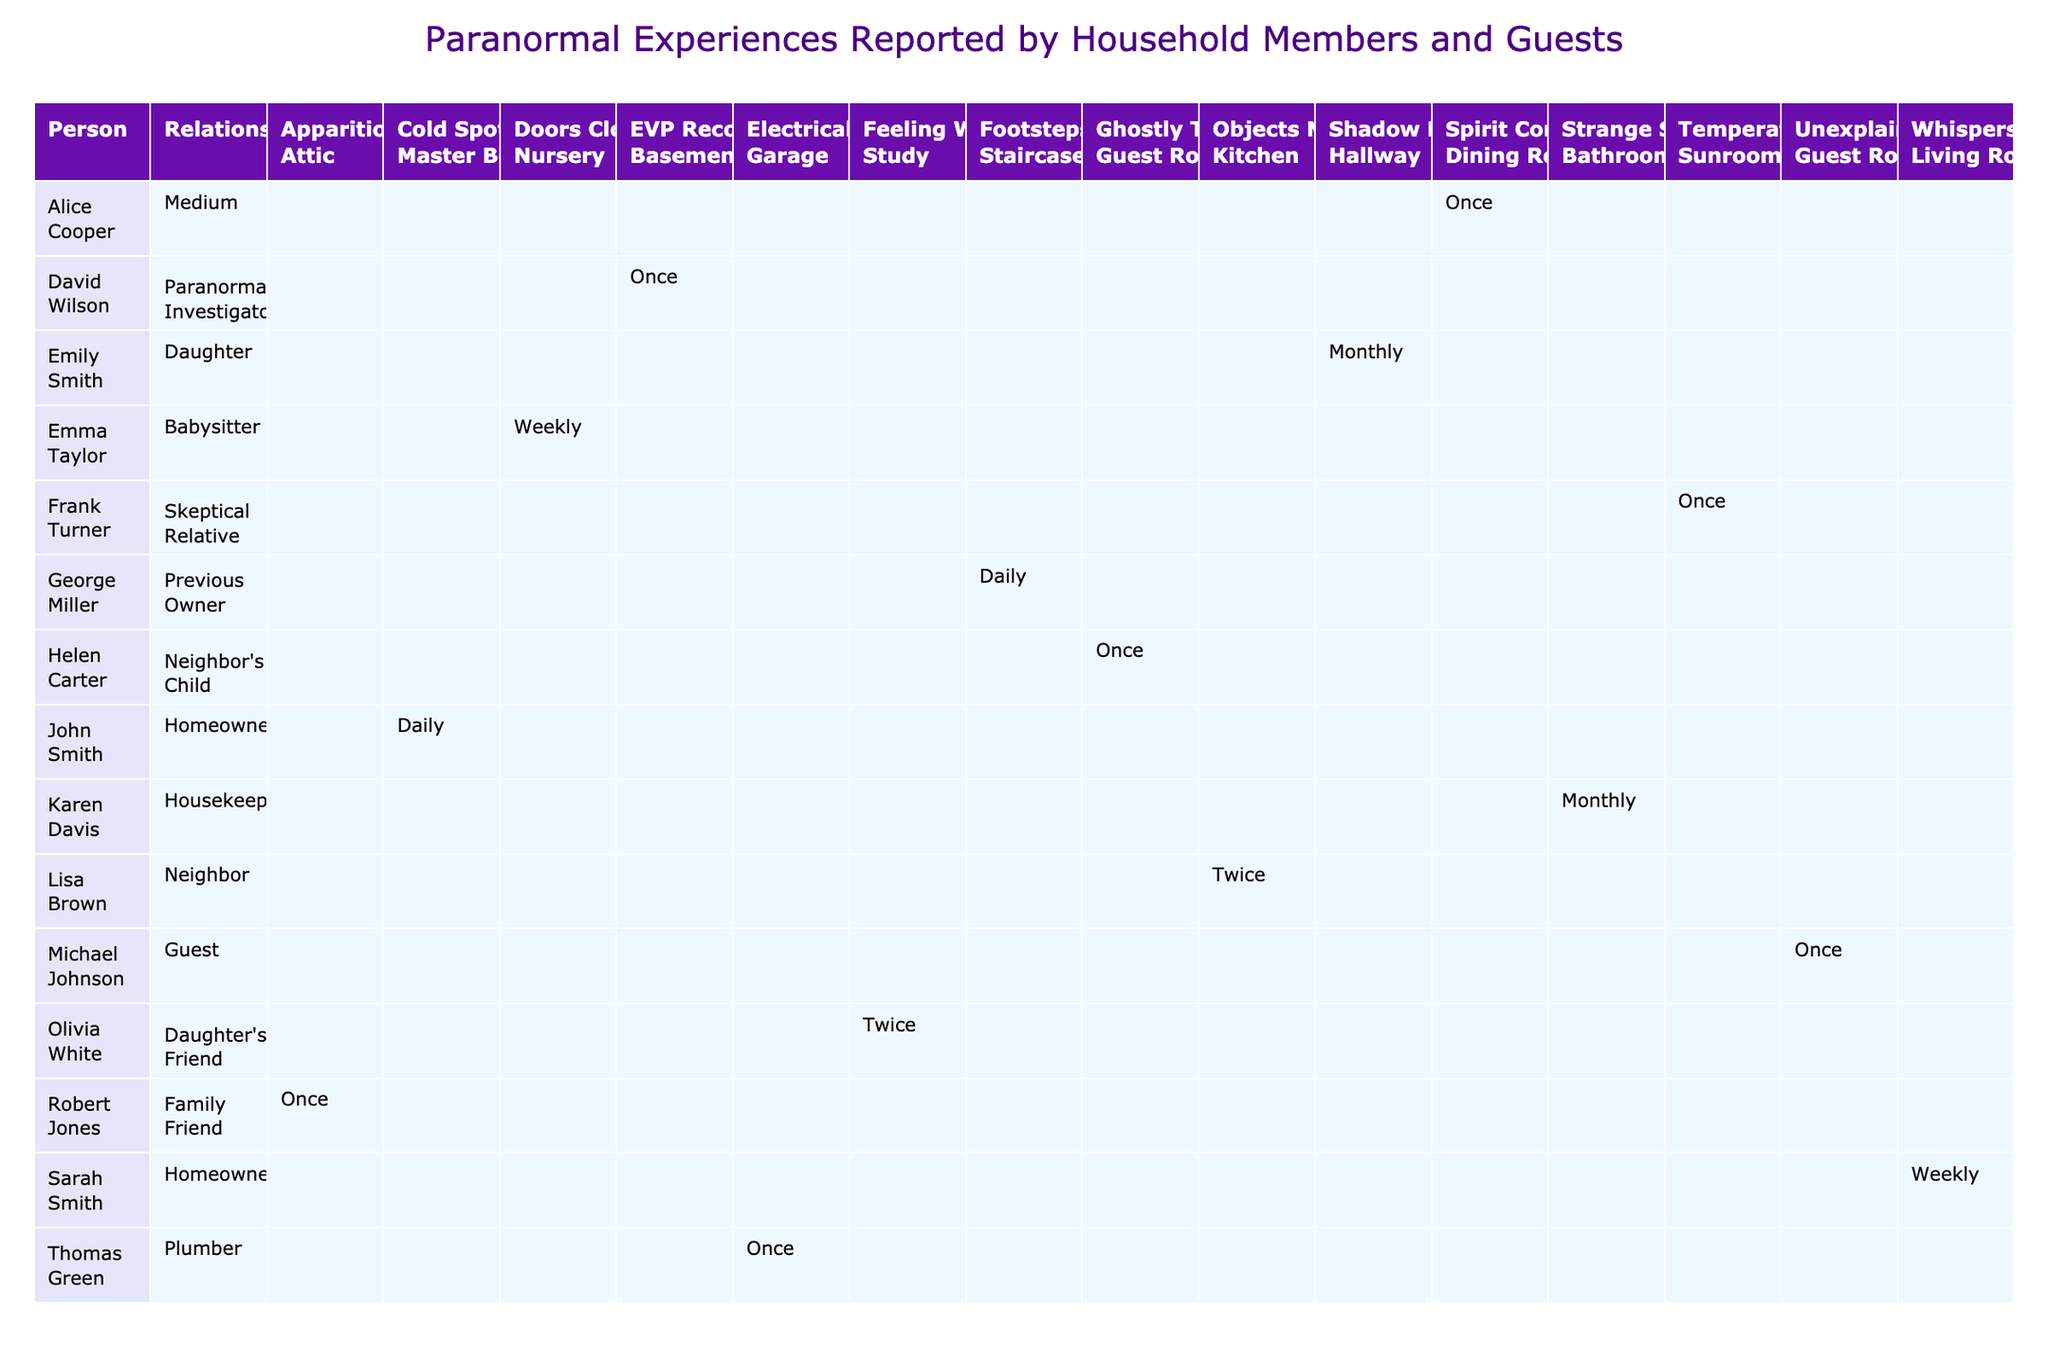What type of paranormal experience does John Smith report? According to the table, John Smith reports experiencing "Cold Spots."
Answer: Cold Spots How many different experience types are reported by Emily Smith? The table shows that Emily Smith reports one experience type, which is "Shadow Figures."
Answer: 1 Which room has the highest number of reported experiences? By examining the table, it is observed that the "Guest Room" has three reported experiences: "Unexplained Noises," "Ghostly Touch," and one experience presumed to be accounted for in "Low" emotional impact.
Answer: Guest Room Is there anyone who reported paranormal experiences specifically in the Nursery? The table indicates that the only reported experience in the Nursery is "Doors Closing" by Emma Taylor. Therefore, the answer is yes.
Answer: Yes What is the emotional impact score associated with Robert Jones's experience? Robert Jones reports seeing an "Apparition," which is classified as having a "Very High" emotional impact according to the table.
Answer: Very High How many household members report experiences during the evening? The table indicates the following members report experiences in the evening: Sarah Smith, Emma Taylor, Olivia White, Alice Cooper. Thus, four household members are noted.
Answer: 4 Who has reported the lowest frequency of experiences and what is it? Michael Johnson and Karen Davis both report experiences at a frequency of "Once," but the lowest frequency reported concerning multiple instances is Karen's "Strange Smells."
Answer: Karen Davis - Once What is the average emotional impact of experiences reported by guests? Guests report "Unexplained Noises" (Low), "Ghostly Touch" (High), and "EVP Recordings" (High). To calculate the average impact, we assign numerical values: Low (1), Medium (2), High (3), Very High (4). The average is calculated as (1 + 3 + 3)/3 = 2.33, which falls into the Medium category.
Answer: Medium Which paranormal investigator reported experiences last and how often? David Wilson, the paranormal investigator, reported "EVP Recordings" once during the night according to the table, making him the last in terms of reported experiences from the provided household members.
Answer: Once 